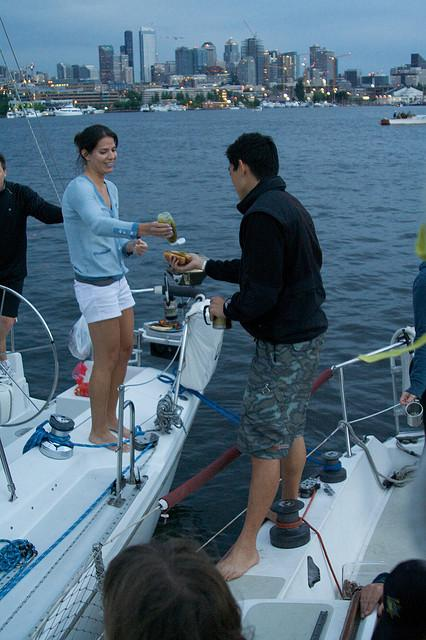What kind of sauce is this? Please explain your reasoning. relish. The condiment coming out of the bottle is green and is being put on a hotdog. 